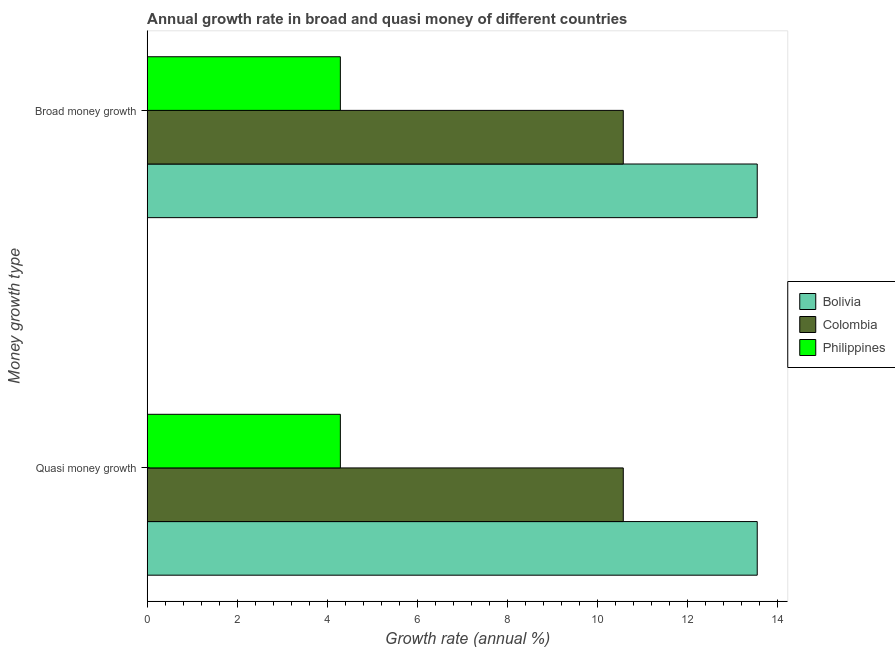How many different coloured bars are there?
Provide a short and direct response. 3. Are the number of bars per tick equal to the number of legend labels?
Provide a short and direct response. Yes. Are the number of bars on each tick of the Y-axis equal?
Your response must be concise. Yes. What is the label of the 2nd group of bars from the top?
Keep it short and to the point. Quasi money growth. What is the annual growth rate in quasi money in Philippines?
Ensure brevity in your answer.  4.29. Across all countries, what is the maximum annual growth rate in quasi money?
Provide a short and direct response. 13.54. Across all countries, what is the minimum annual growth rate in quasi money?
Your answer should be compact. 4.29. In which country was the annual growth rate in quasi money minimum?
Keep it short and to the point. Philippines. What is the total annual growth rate in quasi money in the graph?
Give a very brief answer. 28.39. What is the difference between the annual growth rate in quasi money in Bolivia and that in Philippines?
Provide a short and direct response. 9.25. What is the difference between the annual growth rate in quasi money in Bolivia and the annual growth rate in broad money in Philippines?
Offer a terse response. 9.25. What is the average annual growth rate in broad money per country?
Provide a succinct answer. 9.46. What is the ratio of the annual growth rate in broad money in Colombia to that in Philippines?
Keep it short and to the point. 2.46. Is the annual growth rate in quasi money in Colombia less than that in Bolivia?
Offer a very short reply. Yes. How many bars are there?
Give a very brief answer. 6. What is the difference between two consecutive major ticks on the X-axis?
Keep it short and to the point. 2. Are the values on the major ticks of X-axis written in scientific E-notation?
Give a very brief answer. No. Does the graph contain any zero values?
Make the answer very short. No. Does the graph contain grids?
Your answer should be very brief. No. How many legend labels are there?
Give a very brief answer. 3. What is the title of the graph?
Your answer should be compact. Annual growth rate in broad and quasi money of different countries. Does "Rwanda" appear as one of the legend labels in the graph?
Your response must be concise. No. What is the label or title of the X-axis?
Give a very brief answer. Growth rate (annual %). What is the label or title of the Y-axis?
Your answer should be compact. Money growth type. What is the Growth rate (annual %) of Bolivia in Quasi money growth?
Make the answer very short. 13.54. What is the Growth rate (annual %) in Colombia in Quasi money growth?
Provide a short and direct response. 10.57. What is the Growth rate (annual %) of Philippines in Quasi money growth?
Your response must be concise. 4.29. What is the Growth rate (annual %) in Bolivia in Broad money growth?
Your response must be concise. 13.54. What is the Growth rate (annual %) in Colombia in Broad money growth?
Your response must be concise. 10.57. What is the Growth rate (annual %) in Philippines in Broad money growth?
Your response must be concise. 4.29. Across all Money growth type, what is the maximum Growth rate (annual %) of Bolivia?
Your response must be concise. 13.54. Across all Money growth type, what is the maximum Growth rate (annual %) of Colombia?
Ensure brevity in your answer.  10.57. Across all Money growth type, what is the maximum Growth rate (annual %) of Philippines?
Make the answer very short. 4.29. Across all Money growth type, what is the minimum Growth rate (annual %) in Bolivia?
Ensure brevity in your answer.  13.54. Across all Money growth type, what is the minimum Growth rate (annual %) of Colombia?
Give a very brief answer. 10.57. Across all Money growth type, what is the minimum Growth rate (annual %) in Philippines?
Your answer should be compact. 4.29. What is the total Growth rate (annual %) in Bolivia in the graph?
Offer a very short reply. 27.08. What is the total Growth rate (annual %) of Colombia in the graph?
Your response must be concise. 21.13. What is the total Growth rate (annual %) of Philippines in the graph?
Provide a succinct answer. 8.57. What is the difference between the Growth rate (annual %) of Bolivia in Quasi money growth and that in Broad money growth?
Keep it short and to the point. 0. What is the difference between the Growth rate (annual %) in Colombia in Quasi money growth and that in Broad money growth?
Give a very brief answer. 0. What is the difference between the Growth rate (annual %) in Philippines in Quasi money growth and that in Broad money growth?
Your response must be concise. 0. What is the difference between the Growth rate (annual %) of Bolivia in Quasi money growth and the Growth rate (annual %) of Colombia in Broad money growth?
Make the answer very short. 2.97. What is the difference between the Growth rate (annual %) of Bolivia in Quasi money growth and the Growth rate (annual %) of Philippines in Broad money growth?
Offer a very short reply. 9.25. What is the difference between the Growth rate (annual %) of Colombia in Quasi money growth and the Growth rate (annual %) of Philippines in Broad money growth?
Keep it short and to the point. 6.28. What is the average Growth rate (annual %) of Bolivia per Money growth type?
Provide a succinct answer. 13.54. What is the average Growth rate (annual %) in Colombia per Money growth type?
Make the answer very short. 10.57. What is the average Growth rate (annual %) in Philippines per Money growth type?
Keep it short and to the point. 4.29. What is the difference between the Growth rate (annual %) in Bolivia and Growth rate (annual %) in Colombia in Quasi money growth?
Your response must be concise. 2.97. What is the difference between the Growth rate (annual %) in Bolivia and Growth rate (annual %) in Philippines in Quasi money growth?
Ensure brevity in your answer.  9.25. What is the difference between the Growth rate (annual %) of Colombia and Growth rate (annual %) of Philippines in Quasi money growth?
Ensure brevity in your answer.  6.28. What is the difference between the Growth rate (annual %) of Bolivia and Growth rate (annual %) of Colombia in Broad money growth?
Your answer should be compact. 2.97. What is the difference between the Growth rate (annual %) in Bolivia and Growth rate (annual %) in Philippines in Broad money growth?
Make the answer very short. 9.25. What is the difference between the Growth rate (annual %) in Colombia and Growth rate (annual %) in Philippines in Broad money growth?
Your answer should be very brief. 6.28. What is the ratio of the Growth rate (annual %) in Bolivia in Quasi money growth to that in Broad money growth?
Make the answer very short. 1. What is the difference between the highest and the second highest Growth rate (annual %) of Philippines?
Ensure brevity in your answer.  0. What is the difference between the highest and the lowest Growth rate (annual %) of Bolivia?
Offer a terse response. 0. What is the difference between the highest and the lowest Growth rate (annual %) in Colombia?
Your response must be concise. 0. 